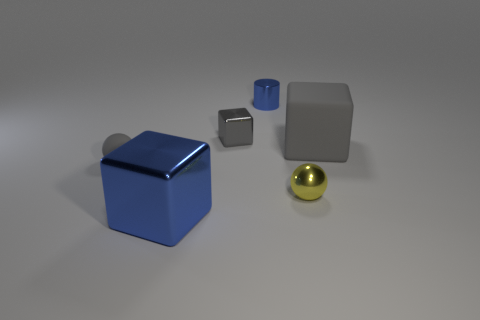There is another metallic thing that is the same shape as the gray shiny thing; what is its color?
Keep it short and to the point. Blue. The matte thing left of the block that is in front of the gray object that is in front of the large matte thing is what shape?
Your answer should be compact. Sphere. There is a metallic thing that is to the left of the yellow metal object and in front of the big rubber object; what is its size?
Offer a very short reply. Large. Are there fewer gray rubber spheres than small cyan metallic cylinders?
Your answer should be compact. No. There is a yellow object on the right side of the tiny gray shiny thing; what size is it?
Provide a short and direct response. Small. There is a metal thing that is on the left side of the tiny blue cylinder and in front of the large rubber object; what is its shape?
Offer a terse response. Cube. The other blue object that is the same shape as the large rubber object is what size?
Offer a very short reply. Large. What number of small yellow things are the same material as the tiny gray ball?
Your answer should be very brief. 0. Does the tiny matte thing have the same color as the large block that is on the left side of the tiny gray cube?
Offer a very short reply. No. Is the number of gray things greater than the number of tiny blue rubber balls?
Ensure brevity in your answer.  Yes. 